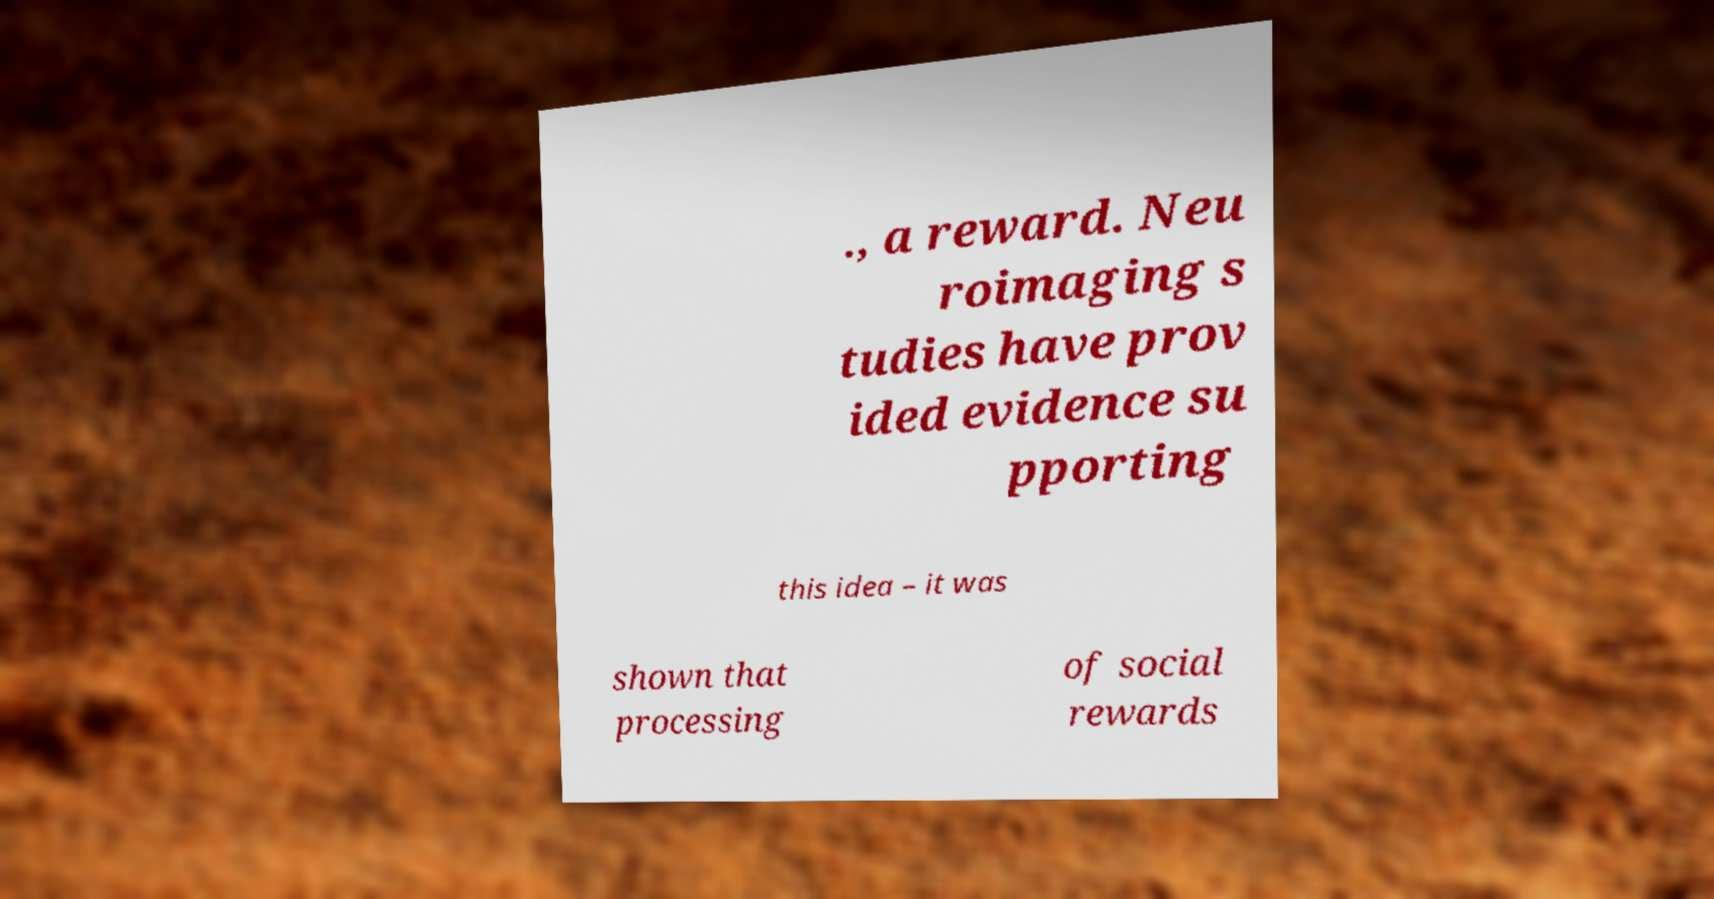Can you accurately transcribe the text from the provided image for me? ., a reward. Neu roimaging s tudies have prov ided evidence su pporting this idea – it was shown that processing of social rewards 